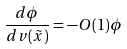Convert formula to latex. <formula><loc_0><loc_0><loc_500><loc_500>\frac { d \phi } { d v ( \tilde { x } ) } = - O ( 1 ) \phi</formula> 